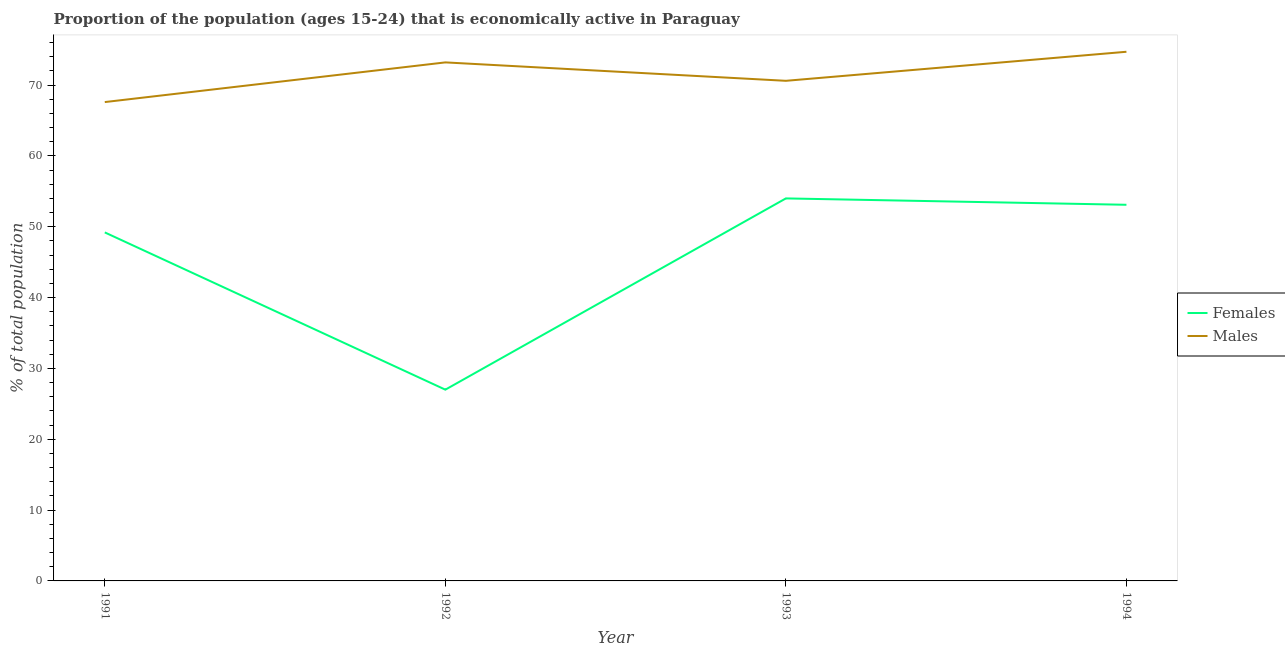Does the line corresponding to percentage of economically active female population intersect with the line corresponding to percentage of economically active male population?
Offer a very short reply. No. What is the percentage of economically active female population in 1994?
Give a very brief answer. 53.1. Across all years, what is the maximum percentage of economically active female population?
Keep it short and to the point. 54. In which year was the percentage of economically active male population maximum?
Your answer should be compact. 1994. In which year was the percentage of economically active female population minimum?
Your answer should be very brief. 1992. What is the total percentage of economically active male population in the graph?
Your answer should be compact. 286.1. What is the difference between the percentage of economically active male population in 1991 and the percentage of economically active female population in 1993?
Offer a very short reply. 13.6. What is the average percentage of economically active male population per year?
Keep it short and to the point. 71.52. In the year 1992, what is the difference between the percentage of economically active male population and percentage of economically active female population?
Give a very brief answer. 46.2. What is the ratio of the percentage of economically active male population in 1992 to that in 1994?
Provide a succinct answer. 0.98. Is the difference between the percentage of economically active female population in 1992 and 1993 greater than the difference between the percentage of economically active male population in 1992 and 1993?
Your answer should be compact. No. What is the difference between the highest and the lowest percentage of economically active female population?
Your response must be concise. 27. Is the sum of the percentage of economically active male population in 1992 and 1994 greater than the maximum percentage of economically active female population across all years?
Offer a very short reply. Yes. Does the percentage of economically active female population monotonically increase over the years?
Offer a terse response. No. Is the percentage of economically active male population strictly greater than the percentage of economically active female population over the years?
Offer a terse response. Yes. How many lines are there?
Offer a very short reply. 2. How many years are there in the graph?
Give a very brief answer. 4. What is the difference between two consecutive major ticks on the Y-axis?
Your response must be concise. 10. Are the values on the major ticks of Y-axis written in scientific E-notation?
Your answer should be compact. No. Does the graph contain any zero values?
Your answer should be compact. No. Does the graph contain grids?
Give a very brief answer. No. Where does the legend appear in the graph?
Offer a terse response. Center right. What is the title of the graph?
Keep it short and to the point. Proportion of the population (ages 15-24) that is economically active in Paraguay. Does "Female" appear as one of the legend labels in the graph?
Provide a short and direct response. No. What is the label or title of the X-axis?
Offer a terse response. Year. What is the label or title of the Y-axis?
Offer a terse response. % of total population. What is the % of total population of Females in 1991?
Offer a terse response. 49.2. What is the % of total population in Males in 1991?
Offer a terse response. 67.6. What is the % of total population in Females in 1992?
Offer a terse response. 27. What is the % of total population of Males in 1992?
Your answer should be compact. 73.2. What is the % of total population of Females in 1993?
Give a very brief answer. 54. What is the % of total population in Males in 1993?
Give a very brief answer. 70.6. What is the % of total population in Females in 1994?
Your answer should be very brief. 53.1. What is the % of total population of Males in 1994?
Your answer should be compact. 74.7. Across all years, what is the maximum % of total population in Males?
Make the answer very short. 74.7. Across all years, what is the minimum % of total population in Males?
Provide a succinct answer. 67.6. What is the total % of total population of Females in the graph?
Your answer should be very brief. 183.3. What is the total % of total population of Males in the graph?
Offer a very short reply. 286.1. What is the difference between the % of total population of Males in 1991 and that in 1992?
Ensure brevity in your answer.  -5.6. What is the difference between the % of total population of Males in 1991 and that in 1993?
Your answer should be compact. -3. What is the difference between the % of total population of Females in 1991 and that in 1994?
Keep it short and to the point. -3.9. What is the difference between the % of total population in Males in 1992 and that in 1993?
Your response must be concise. 2.6. What is the difference between the % of total population of Females in 1992 and that in 1994?
Your answer should be compact. -26.1. What is the difference between the % of total population of Males in 1992 and that in 1994?
Your response must be concise. -1.5. What is the difference between the % of total population of Females in 1991 and the % of total population of Males in 1992?
Offer a terse response. -24. What is the difference between the % of total population in Females in 1991 and the % of total population in Males in 1993?
Offer a very short reply. -21.4. What is the difference between the % of total population of Females in 1991 and the % of total population of Males in 1994?
Your response must be concise. -25.5. What is the difference between the % of total population in Females in 1992 and the % of total population in Males in 1993?
Provide a short and direct response. -43.6. What is the difference between the % of total population in Females in 1992 and the % of total population in Males in 1994?
Provide a succinct answer. -47.7. What is the difference between the % of total population of Females in 1993 and the % of total population of Males in 1994?
Offer a terse response. -20.7. What is the average % of total population of Females per year?
Provide a succinct answer. 45.83. What is the average % of total population of Males per year?
Offer a very short reply. 71.53. In the year 1991, what is the difference between the % of total population of Females and % of total population of Males?
Make the answer very short. -18.4. In the year 1992, what is the difference between the % of total population of Females and % of total population of Males?
Ensure brevity in your answer.  -46.2. In the year 1993, what is the difference between the % of total population of Females and % of total population of Males?
Provide a short and direct response. -16.6. In the year 1994, what is the difference between the % of total population in Females and % of total population in Males?
Your answer should be compact. -21.6. What is the ratio of the % of total population of Females in 1991 to that in 1992?
Make the answer very short. 1.82. What is the ratio of the % of total population in Males in 1991 to that in 1992?
Provide a succinct answer. 0.92. What is the ratio of the % of total population in Females in 1991 to that in 1993?
Give a very brief answer. 0.91. What is the ratio of the % of total population of Males in 1991 to that in 1993?
Your answer should be compact. 0.96. What is the ratio of the % of total population in Females in 1991 to that in 1994?
Give a very brief answer. 0.93. What is the ratio of the % of total population in Males in 1991 to that in 1994?
Ensure brevity in your answer.  0.91. What is the ratio of the % of total population of Males in 1992 to that in 1993?
Your response must be concise. 1.04. What is the ratio of the % of total population in Females in 1992 to that in 1994?
Offer a very short reply. 0.51. What is the ratio of the % of total population of Males in 1992 to that in 1994?
Offer a terse response. 0.98. What is the ratio of the % of total population in Females in 1993 to that in 1994?
Offer a terse response. 1.02. What is the ratio of the % of total population in Males in 1993 to that in 1994?
Provide a short and direct response. 0.95. What is the difference between the highest and the lowest % of total population of Males?
Keep it short and to the point. 7.1. 